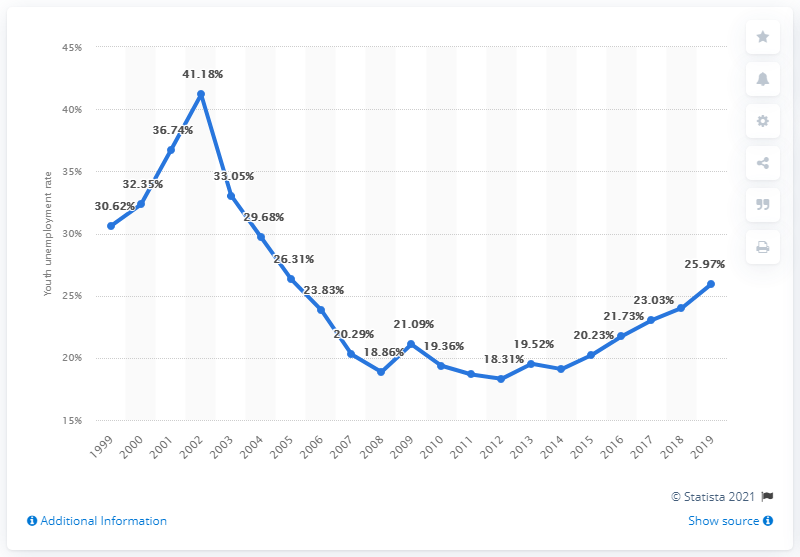Identify some key points in this picture. In 2019, the youth unemployment rate in Argentina was 25.97%. 